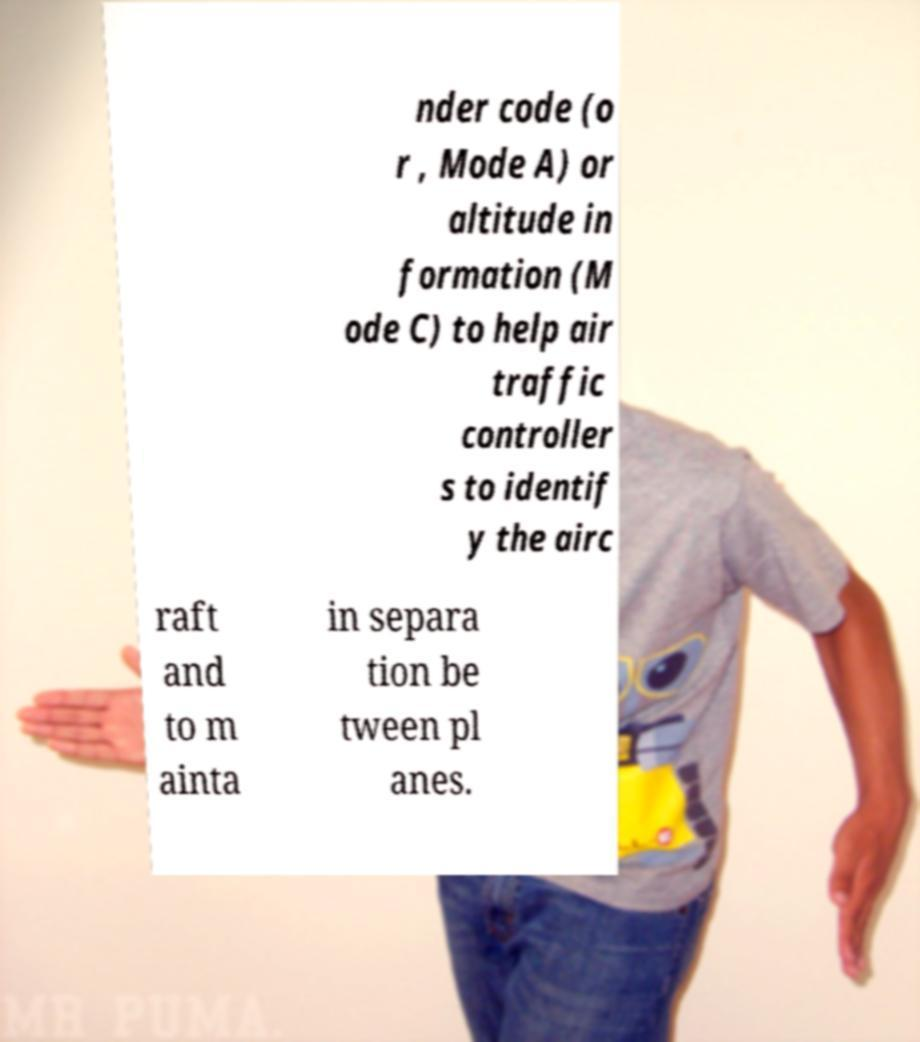There's text embedded in this image that I need extracted. Can you transcribe it verbatim? nder code (o r , Mode A) or altitude in formation (M ode C) to help air traffic controller s to identif y the airc raft and to m ainta in separa tion be tween pl anes. 